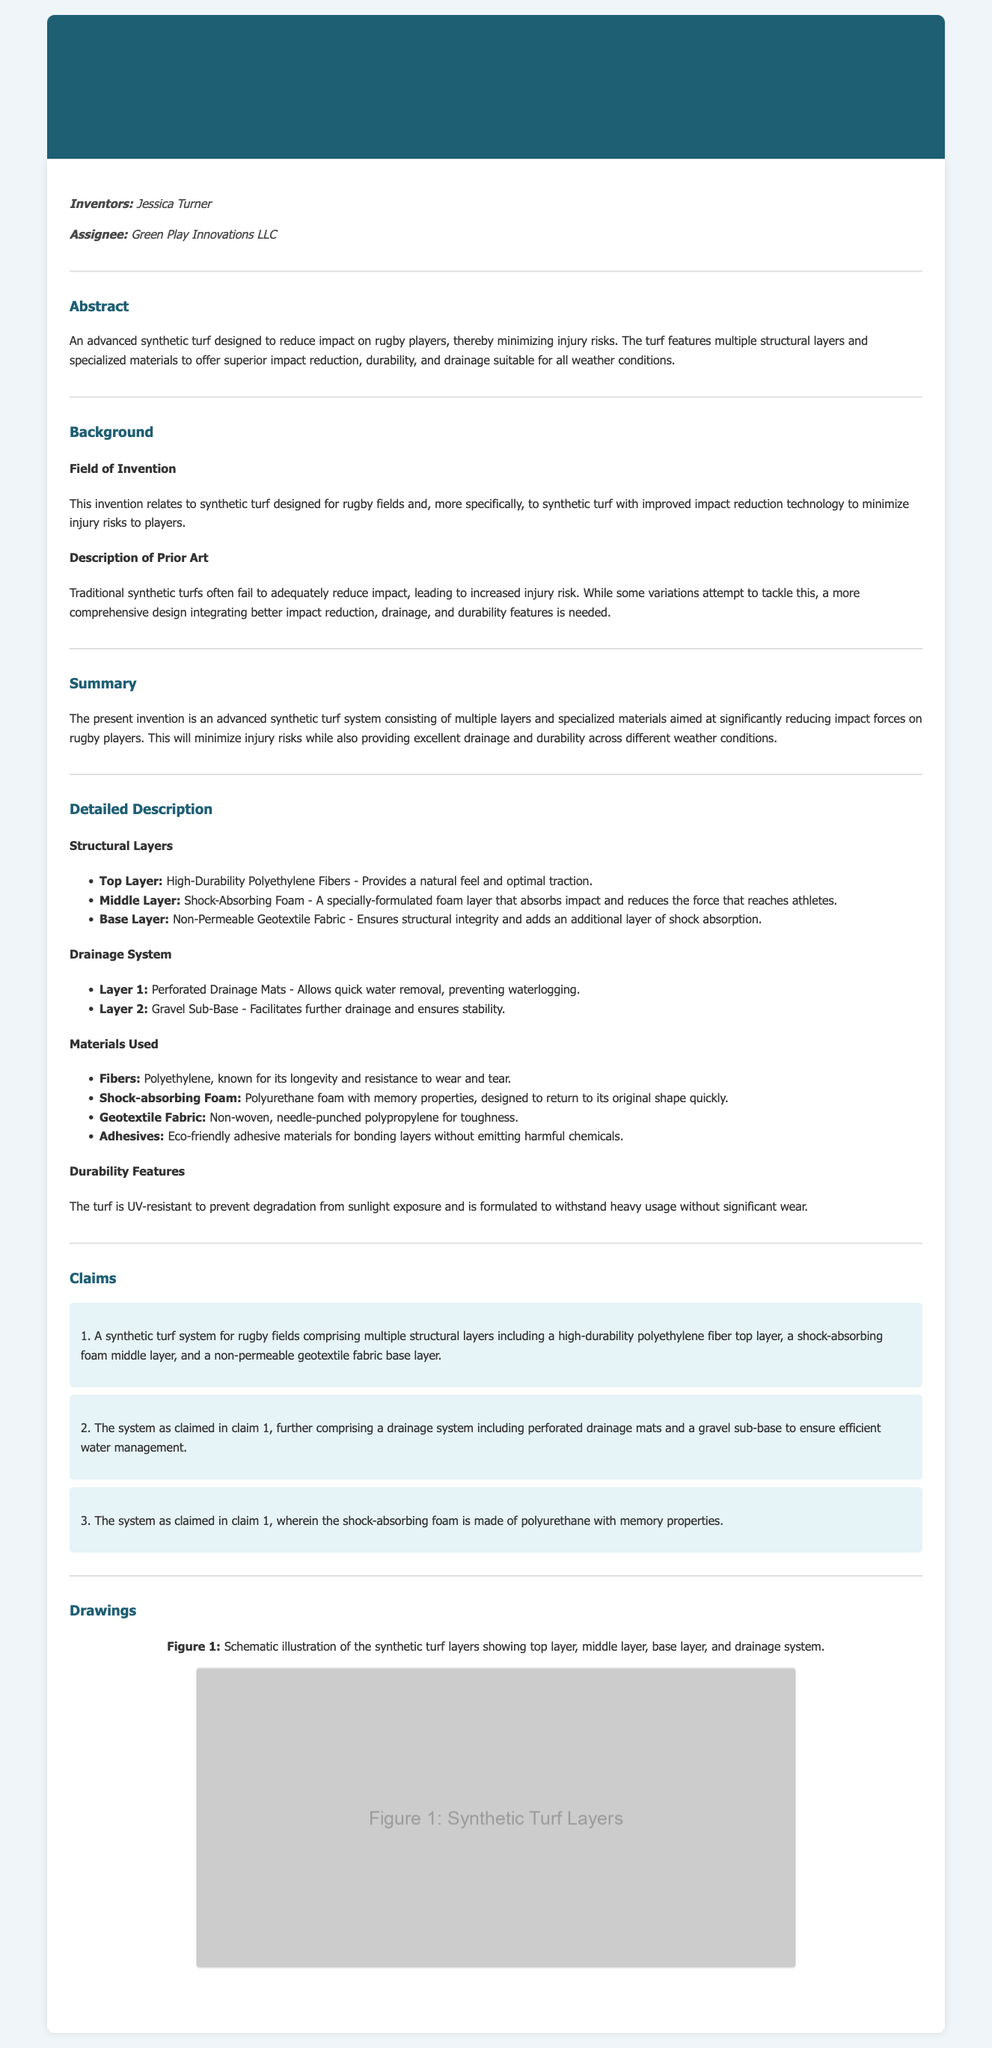What is the invention related to? The invention relates to synthetic turf designed for rugby fields.
Answer: Synthetic turf designed for rugby fields Who is the inventor of the patent? The inventor's name is mentioned in the document.
Answer: Jessica Turner What material is used in the top layer? The document specifies what the top layer is made of.
Answer: High-Durability Polyethylene Fibers How many claims are there in the document? The number of claims listed in the claims section can be counted.
Answer: 3 What feature helps with water management? The drainage system in the document includes specific components.
Answer: Perforated Drainage Mats What type of foam is used in the middle layer? The document specifies the type of foam.
Answer: Polyurethane foam What is the primary benefit of the synthetic turf? The document states the main advantage of the synthetic turf.
Answer: Minimize injury risks What is the assignee's name? The name of the assignee is explicitly mentioned in the document.
Answer: Green Play Innovations LLC What type of fabric is used in the base layer? The document details the material used in the base layer.
Answer: Non-Permeable Geotextile Fabric 